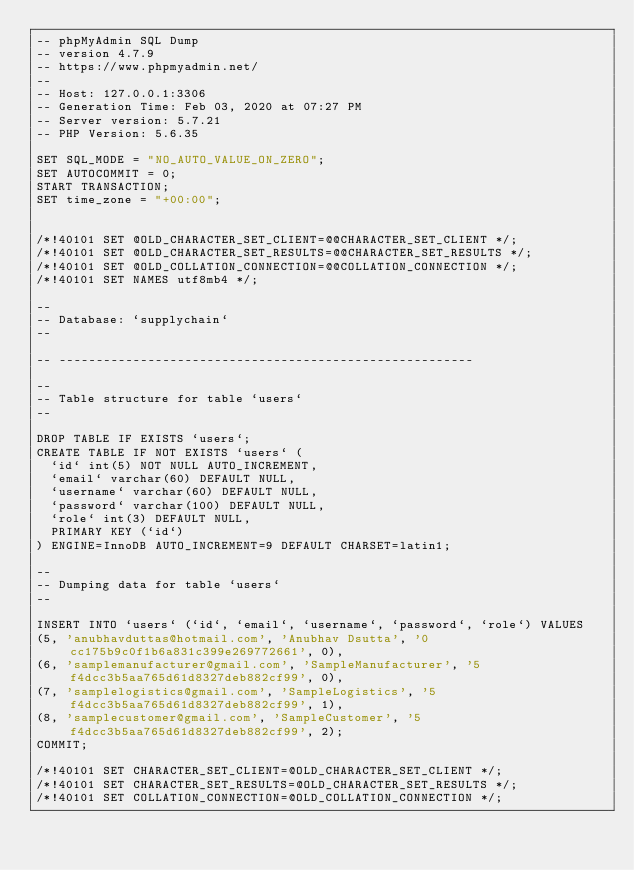<code> <loc_0><loc_0><loc_500><loc_500><_SQL_>-- phpMyAdmin SQL Dump
-- version 4.7.9
-- https://www.phpmyadmin.net/
--
-- Host: 127.0.0.1:3306
-- Generation Time: Feb 03, 2020 at 07:27 PM
-- Server version: 5.7.21
-- PHP Version: 5.6.35

SET SQL_MODE = "NO_AUTO_VALUE_ON_ZERO";
SET AUTOCOMMIT = 0;
START TRANSACTION;
SET time_zone = "+00:00";


/*!40101 SET @OLD_CHARACTER_SET_CLIENT=@@CHARACTER_SET_CLIENT */;
/*!40101 SET @OLD_CHARACTER_SET_RESULTS=@@CHARACTER_SET_RESULTS */;
/*!40101 SET @OLD_COLLATION_CONNECTION=@@COLLATION_CONNECTION */;
/*!40101 SET NAMES utf8mb4 */;

--
-- Database: `supplychain`
--

-- --------------------------------------------------------

--
-- Table structure for table `users`
--

DROP TABLE IF EXISTS `users`;
CREATE TABLE IF NOT EXISTS `users` (
  `id` int(5) NOT NULL AUTO_INCREMENT,
  `email` varchar(60) DEFAULT NULL,
  `username` varchar(60) DEFAULT NULL,
  `password` varchar(100) DEFAULT NULL,
  `role` int(3) DEFAULT NULL,
  PRIMARY KEY (`id`)
) ENGINE=InnoDB AUTO_INCREMENT=9 DEFAULT CHARSET=latin1;

--
-- Dumping data for table `users`
--

INSERT INTO `users` (`id`, `email`, `username`, `password`, `role`) VALUES
(5, 'anubhavduttas@hotmail.com', 'Anubhav Dsutta', '0cc175b9c0f1b6a831c399e269772661', 0),
(6, 'samplemanufacturer@gmail.com', 'SampleManufacturer', '5f4dcc3b5aa765d61d8327deb882cf99', 0),
(7, 'samplelogistics@gmail.com', 'SampleLogistics', '5f4dcc3b5aa765d61d8327deb882cf99', 1),
(8, 'samplecustomer@gmail.com', 'SampleCustomer', '5f4dcc3b5aa765d61d8327deb882cf99', 2);
COMMIT;

/*!40101 SET CHARACTER_SET_CLIENT=@OLD_CHARACTER_SET_CLIENT */;
/*!40101 SET CHARACTER_SET_RESULTS=@OLD_CHARACTER_SET_RESULTS */;
/*!40101 SET COLLATION_CONNECTION=@OLD_COLLATION_CONNECTION */;
</code> 